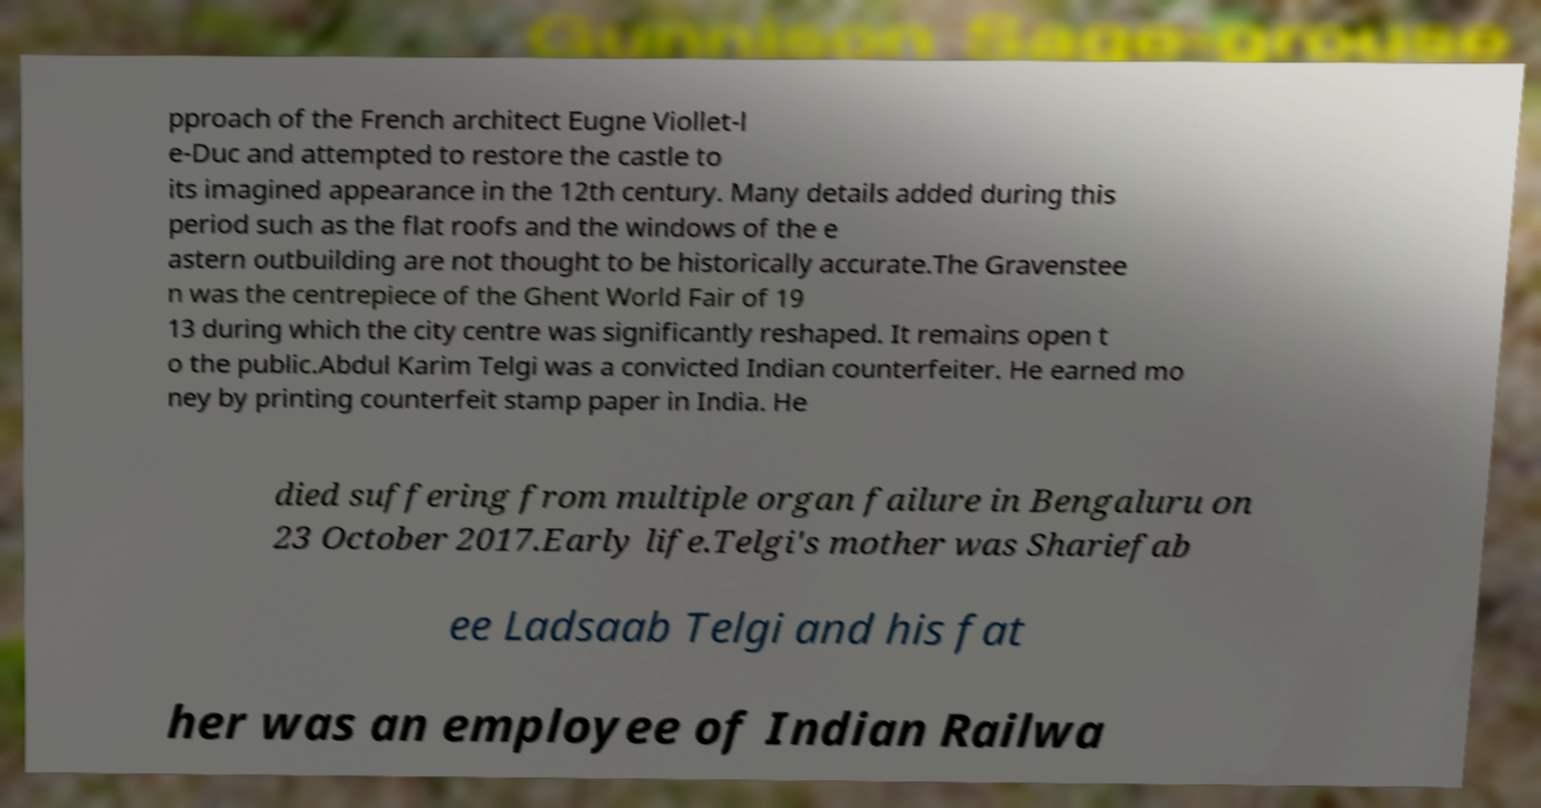Can you accurately transcribe the text from the provided image for me? pproach of the French architect Eugne Viollet-l e-Duc and attempted to restore the castle to its imagined appearance in the 12th century. Many details added during this period such as the flat roofs and the windows of the e astern outbuilding are not thought to be historically accurate.The Gravenstee n was the centrepiece of the Ghent World Fair of 19 13 during which the city centre was significantly reshaped. It remains open t o the public.Abdul Karim Telgi was a convicted Indian counterfeiter. He earned mo ney by printing counterfeit stamp paper in India. He died suffering from multiple organ failure in Bengaluru on 23 October 2017.Early life.Telgi's mother was Shariefab ee Ladsaab Telgi and his fat her was an employee of Indian Railwa 